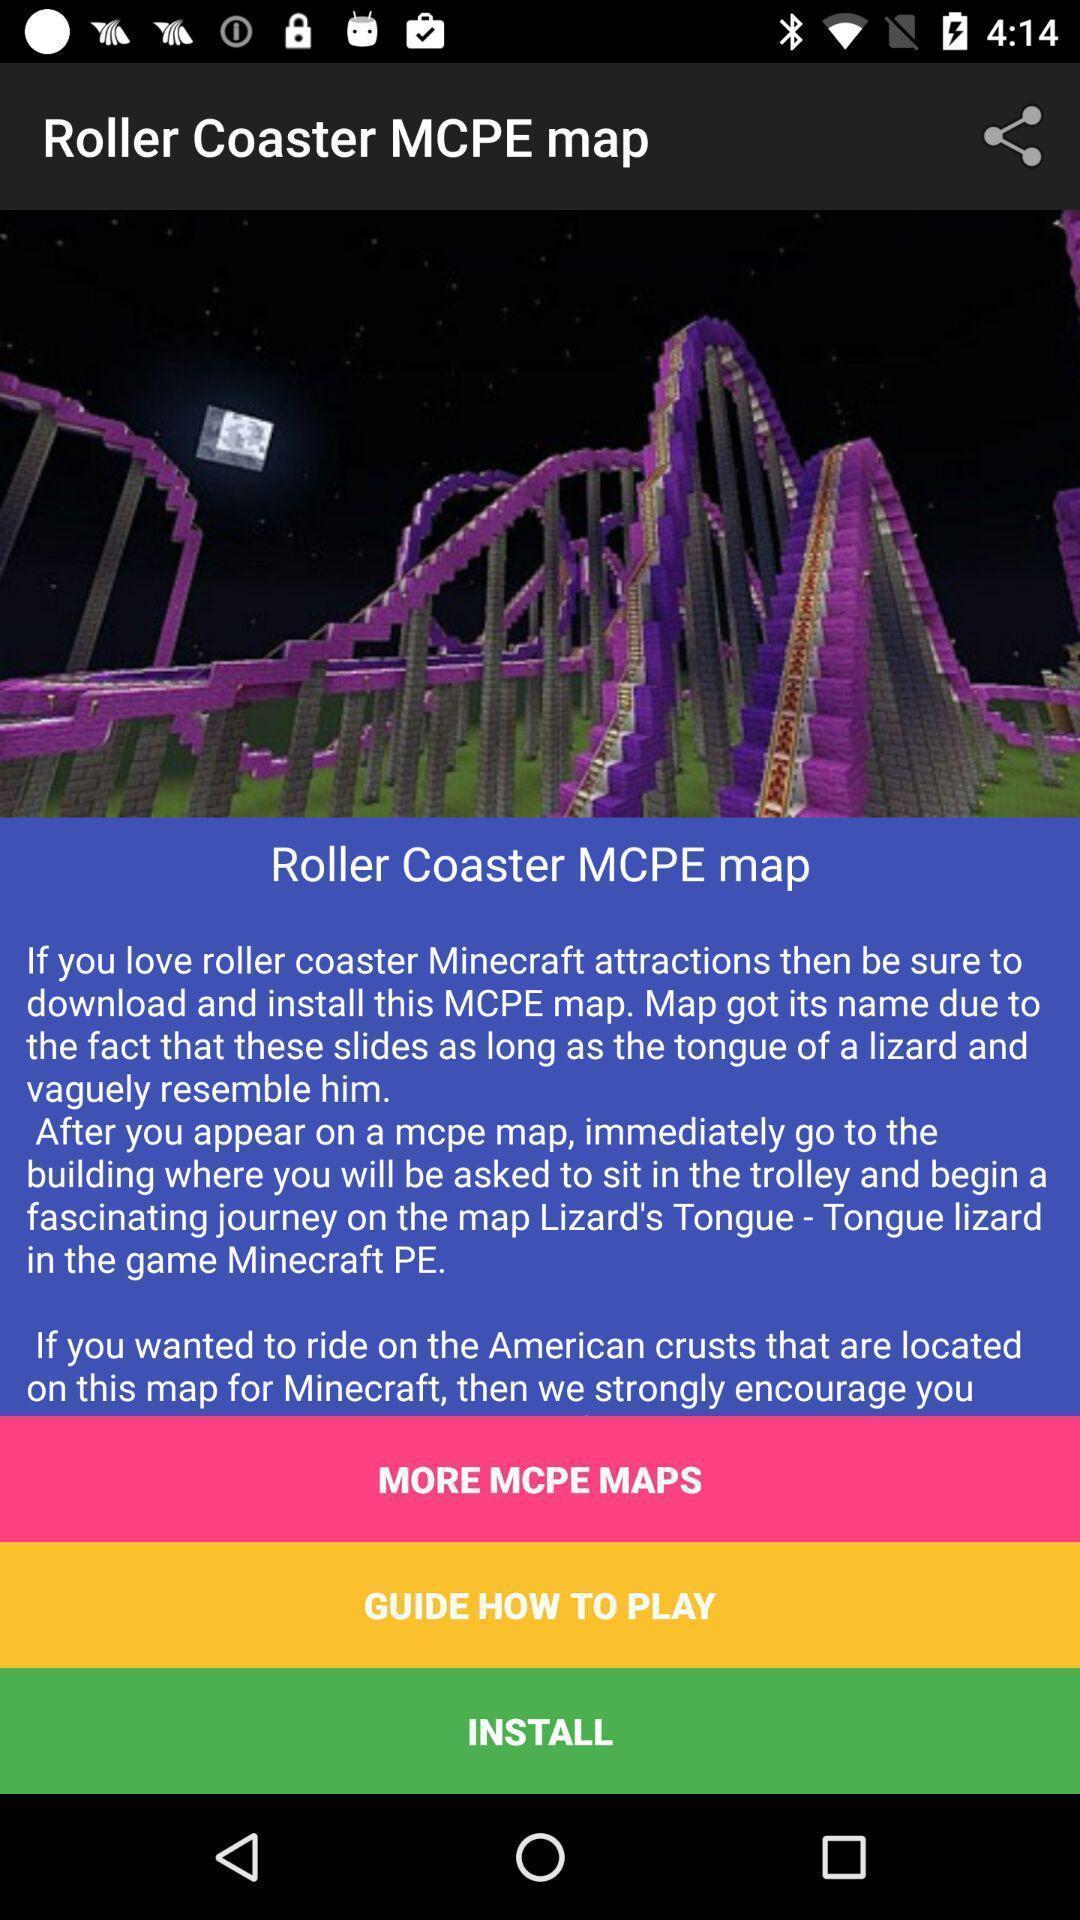What can you discern from this picture? Welcome page of a gaming app. 